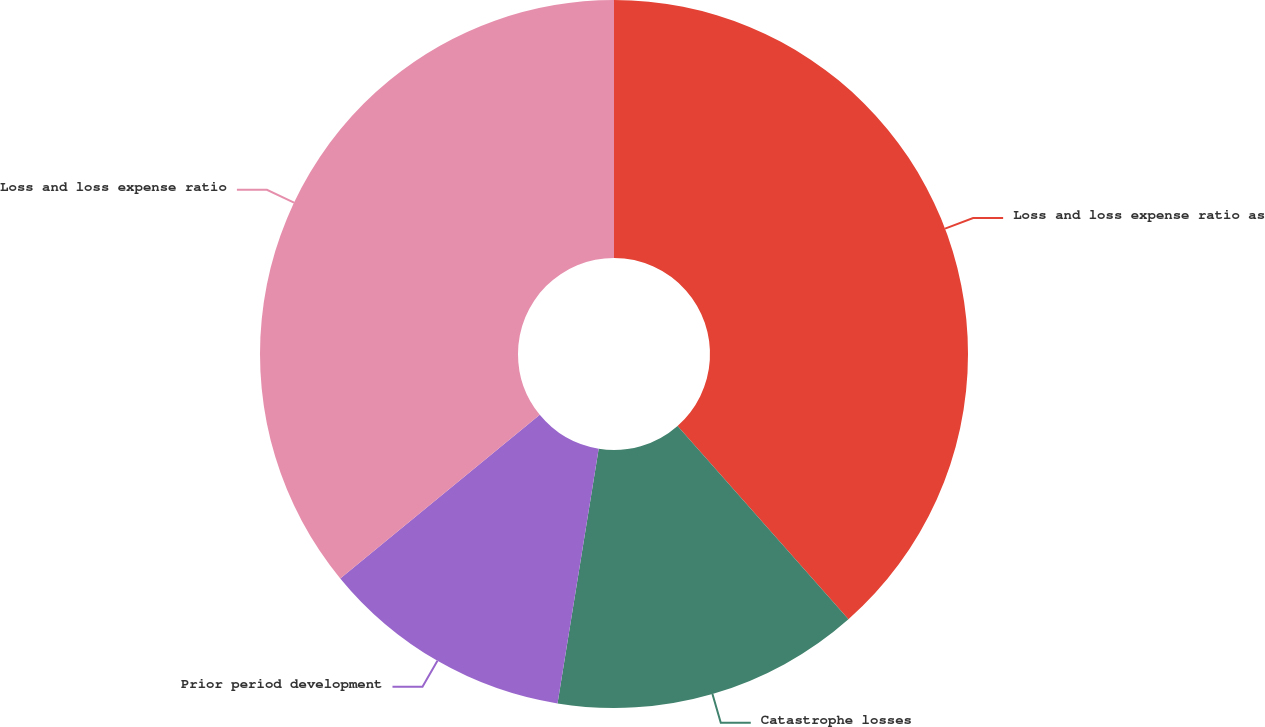<chart> <loc_0><loc_0><loc_500><loc_500><pie_chart><fcel>Loss and loss expense ratio as<fcel>Catastrophe losses<fcel>Prior period development<fcel>Loss and loss expense ratio<nl><fcel>38.48%<fcel>14.07%<fcel>11.52%<fcel>35.93%<nl></chart> 